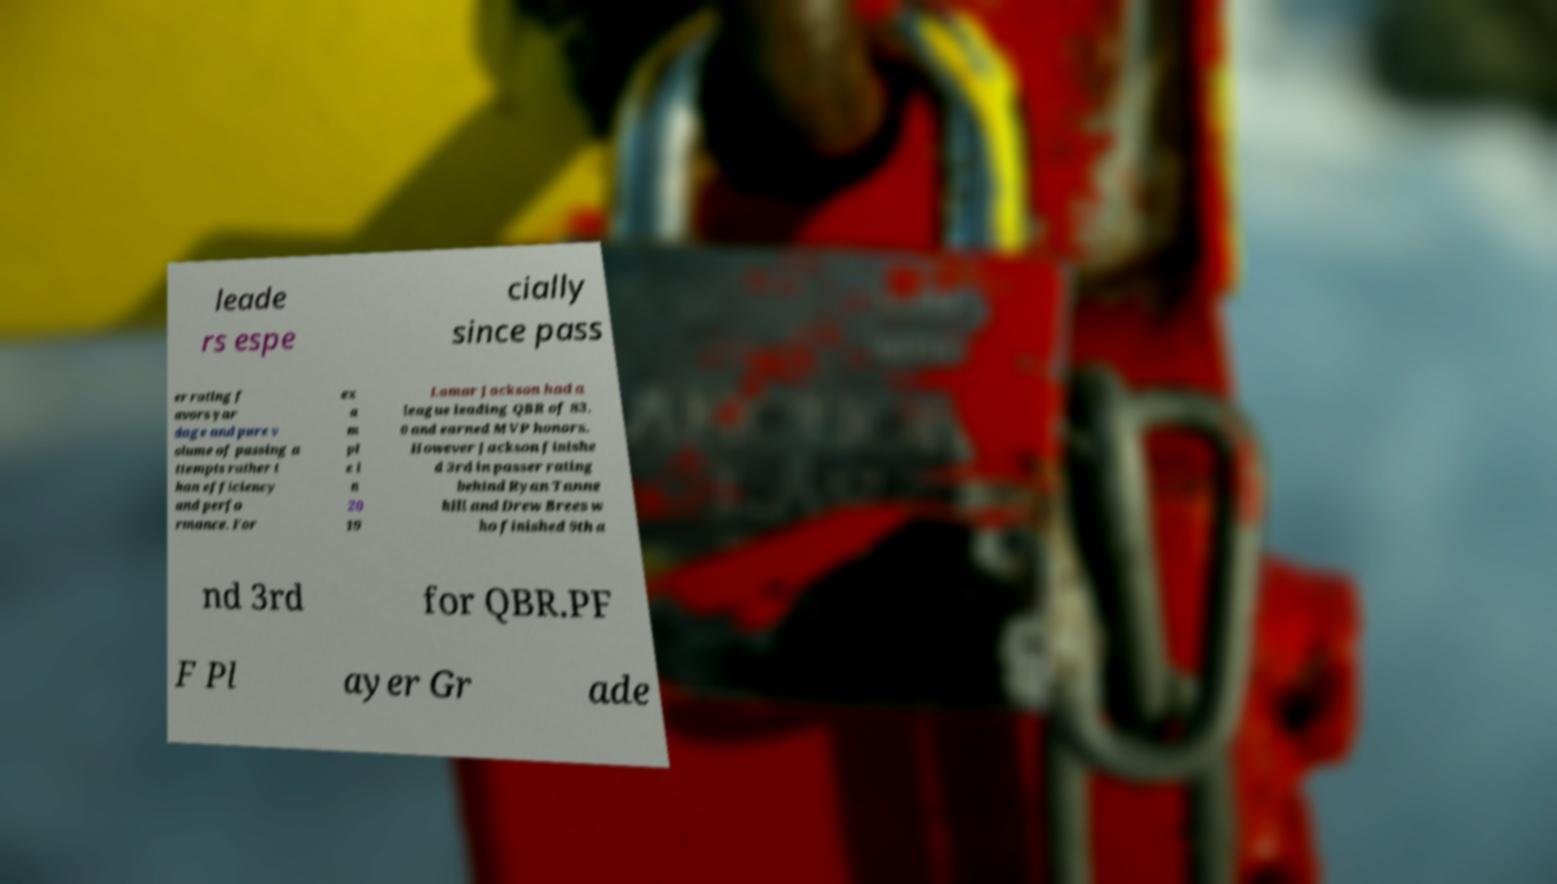Please identify and transcribe the text found in this image. leade rs espe cially since pass er rating f avors yar dage and pure v olume of passing a ttempts rather t han efficiency and perfo rmance. For ex a m pl e i n 20 19 Lamar Jackson had a league leading QBR of 83. 0 and earned MVP honors. However Jackson finishe d 3rd in passer rating behind Ryan Tanne hill and Drew Brees w ho finished 9th a nd 3rd for QBR.PF F Pl ayer Gr ade 